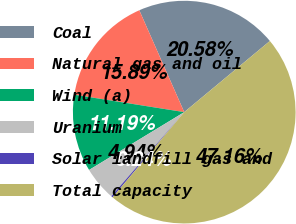Convert chart to OTSL. <chart><loc_0><loc_0><loc_500><loc_500><pie_chart><fcel>Coal<fcel>Natural gas and oil<fcel>Wind (a)<fcel>Uranium<fcel>Solar landfill gas and<fcel>Total capacity<nl><fcel>20.58%<fcel>15.89%<fcel>11.19%<fcel>4.94%<fcel>0.24%<fcel>47.16%<nl></chart> 